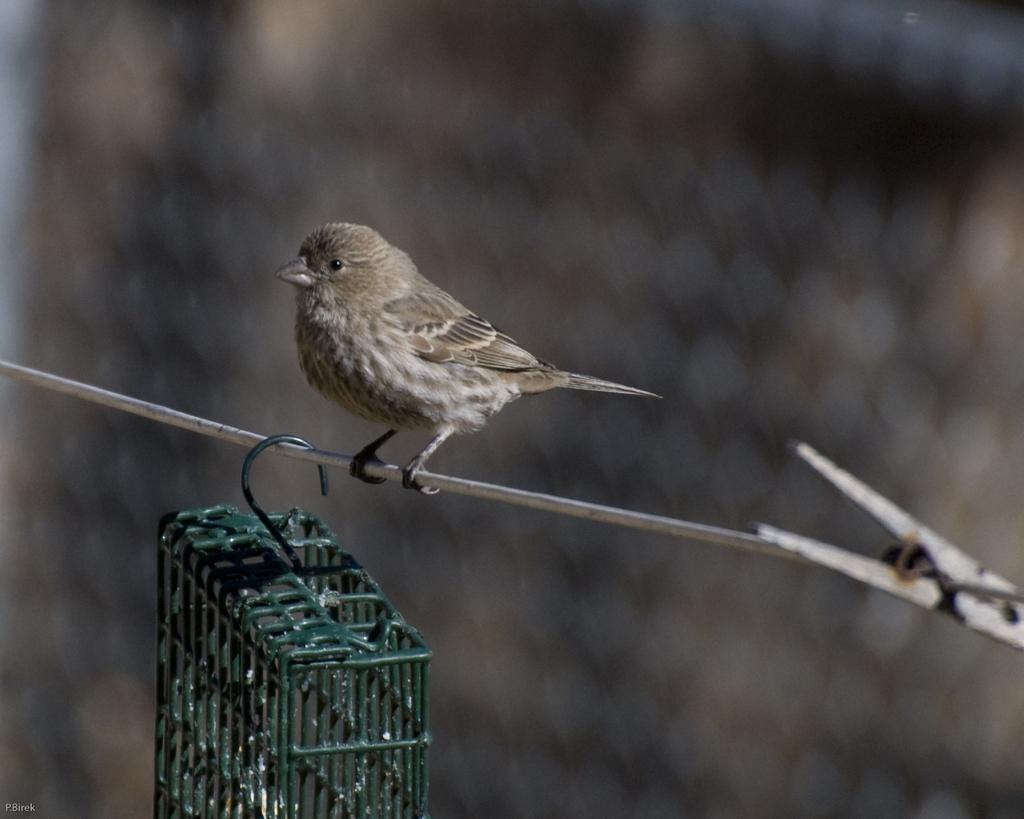What is the main subject of the image? The main subject of the image is a bird on a wire. What is located below the wire? There is a cage visible below the wire. Can you describe the background of the image? The background of the image is blurry. What reward does the bird receive for staying on the wire for a month? There is no mention of a reward or a time period in the image, and the bird's actions are not being evaluated or rewarded. 